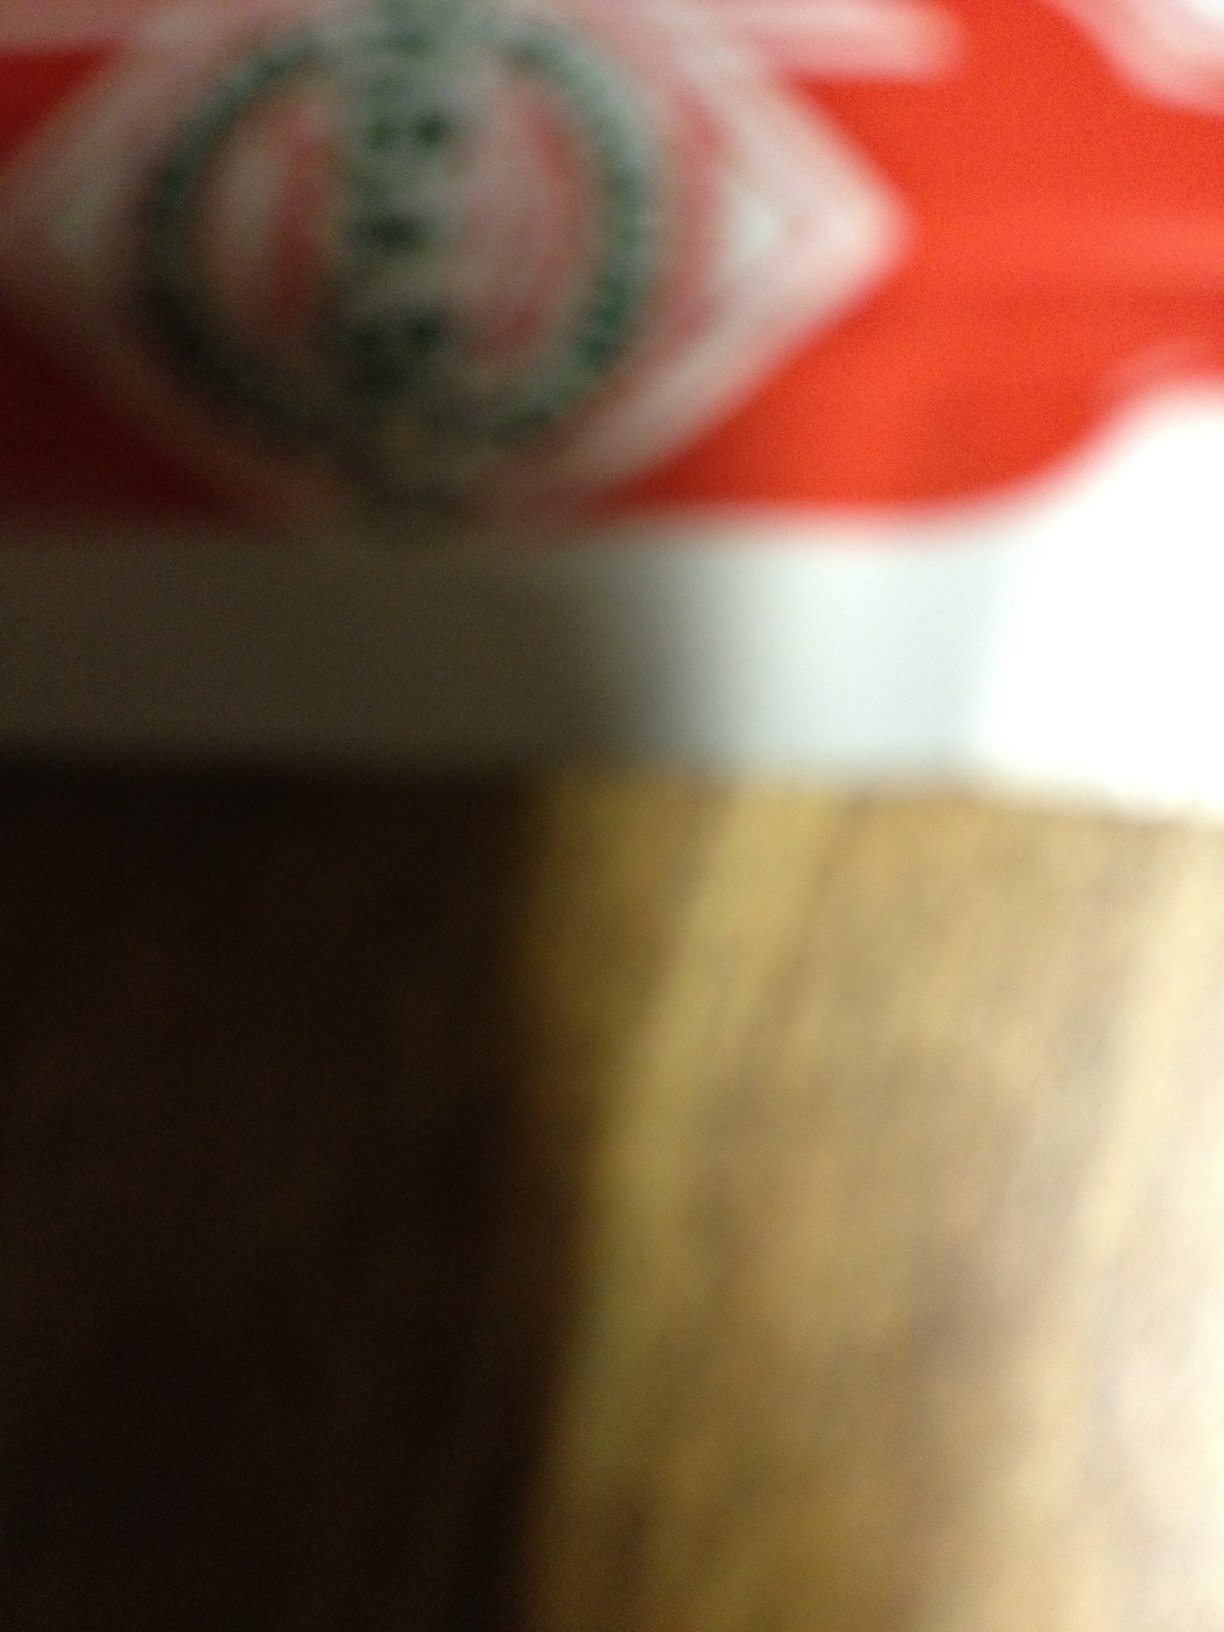Can you guess what is inside this package based on its color scheme? The colors red and green are often associated with food items, particularly snack foods or festive treats. However, without clearer details, this is just a speculative guess. 